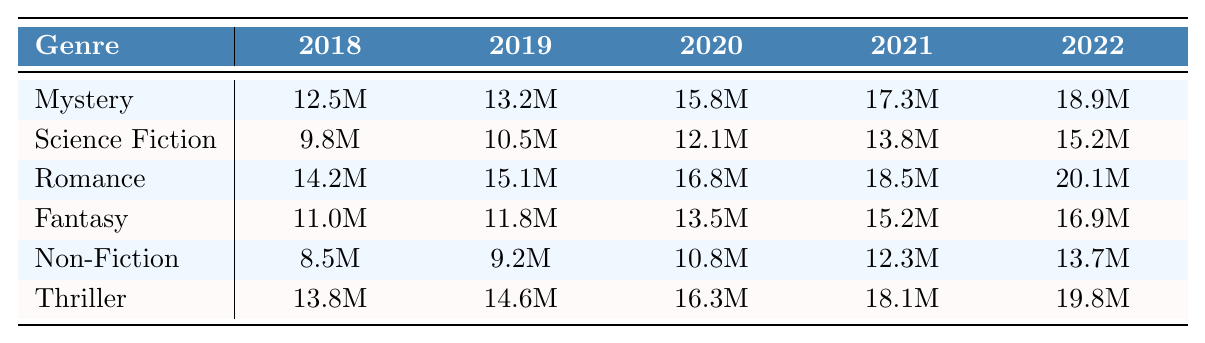What was the total global sales figure for the Romance genre in 2022? The table shows that the global sales figure for the Romance genre in 2022 is 20.1 million.
Answer: 20.1M Which genre had the highest sales in 2021? In 2021, the genre with the highest sales is Romance, with 18.5 million, compared to the other genres listed.
Answer: Romance What is the average sales figure for the Non-Fiction genre from 2018 to 2022? The sales figures for Non-Fiction are 8.5M, 9.2M, 10.8M, 12.3M, and 13.7M. Adding these gives 54.5M, and dividing by 5 results in an average of 10.9M.
Answer: 10.9M Did the sales of Science Fiction increase every year from 2018 to 2022? Looking at the sales figures, Science Fiction shows yearly increases: from 9.8M to 15.2M with no declines during the period.
Answer: Yes What was the difference between the total sales of Mystery and Fantasy in 2020? The total sales for Mystery in 2020 is 15.8M and for Fantasy it is 13.5M. The difference is 15.8M - 13.5M = 2.3M.
Answer: 2.3M Which genre saw the most significant increase in sales from 2018 to 2022? The increases for each genre from 2018 to 2022 were: Mystery (7.4M), Science Fiction (5.2M), Romance (5.9M), Fantasy (5.9M), Non-Fiction (5.2M), and Thriller (6M). Thriller had the highest increase of 6M.
Answer: Thriller In which year did the Thriller genre reach a sales figure of 18 million for the first time? Looking at the table, the Thriller genre reached 18 million in 2021, which is the first time this figure appears.
Answer: 2021 What is the total global sales figure for all genres combined in 2022? Adding the sales figures for 2022 from all genres: 18.9M (Mystery) + 15.2M (Science Fiction) + 20.1M (Romance) + 16.9M (Fantasy) + 13.7M (Non-Fiction) + 19.8M (Thriller) = 104.6M.
Answer: 104.6M What is the trend in global sales figures for audio-based literature from 2018 to 2022? Analyzing the data, all genres show an increasing trend in global sales figures from 2018 to 2022. All reported sales values increased every year.
Answer: Increasing trend 